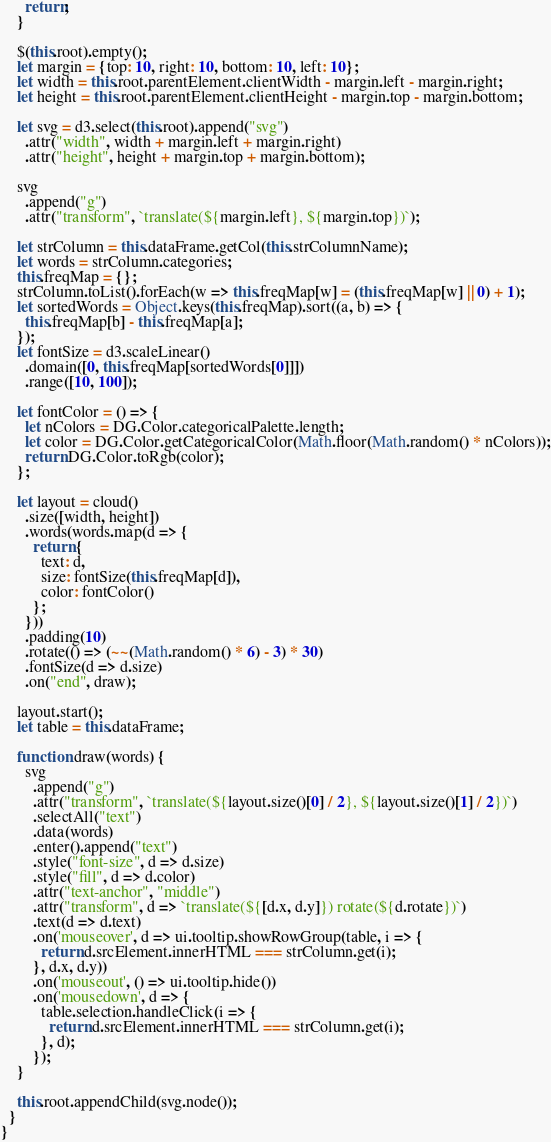Convert code to text. <code><loc_0><loc_0><loc_500><loc_500><_JavaScript_>      return;
    }

    $(this.root).empty();
    let margin = {top: 10, right: 10, bottom: 10, left: 10};
    let width = this.root.parentElement.clientWidth - margin.left - margin.right;
    let height = this.root.parentElement.clientHeight - margin.top - margin.bottom;

    let svg = d3.select(this.root).append("svg")
      .attr("width", width + margin.left + margin.right)
      .attr("height", height + margin.top + margin.bottom);

    svg
      .append("g")
      .attr("transform", `translate(${margin.left}, ${margin.top})`);

    let strColumn = this.dataFrame.getCol(this.strColumnName);
    let words = strColumn.categories;
    this.freqMap = {};
    strColumn.toList().forEach(w => this.freqMap[w] = (this.freqMap[w] || 0) + 1);
    let sortedWords = Object.keys(this.freqMap).sort((a, b) => {
      this.freqMap[b] - this.freqMap[a];
    });
    let fontSize = d3.scaleLinear()
      .domain([0, this.freqMap[sortedWords[0]]])
      .range([10, 100]);

    let fontColor = () => {
      let nColors = DG.Color.categoricalPalette.length;
      let color = DG.Color.getCategoricalColor(Math.floor(Math.random() * nColors));
      return DG.Color.toRgb(color);
    };

    let layout = cloud()
      .size([width, height])
      .words(words.map(d => {
        return {
          text: d,
          size: fontSize(this.freqMap[d]),
          color: fontColor()
        };
      }))
      .padding(10)
      .rotate(() => (~~(Math.random() * 6) - 3) * 30)
      .fontSize(d => d.size)
      .on("end", draw);

    layout.start();
    let table = this.dataFrame;

    function draw(words) {
      svg
        .append("g")
        .attr("transform", `translate(${layout.size()[0] / 2}, ${layout.size()[1] / 2})`)
        .selectAll("text")
        .data(words)
        .enter().append("text")
        .style("font-size", d => d.size)
        .style("fill", d => d.color)
        .attr("text-anchor", "middle")
        .attr("transform", d => `translate(${[d.x, d.y]}) rotate(${d.rotate})`)
        .text(d => d.text)
        .on('mouseover', d => ui.tooltip.showRowGroup(table, i => {
          return d.srcElement.innerHTML === strColumn.get(i);
        }, d.x, d.y))
        .on('mouseout', () => ui.tooltip.hide())
        .on('mousedown', d => {
          table.selection.handleClick(i => {
            return d.srcElement.innerHTML === strColumn.get(i);
          }, d);
        });
    }

    this.root.appendChild(svg.node());
  }
}
</code> 